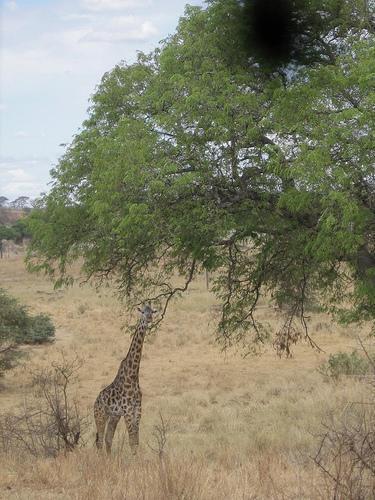How many giraffes are eating leaves?
Give a very brief answer. 1. How many giraffes?
Give a very brief answer. 1. How many different species of animals do you see?
Give a very brief answer. 1. How many animals do you see?
Give a very brief answer. 1. 